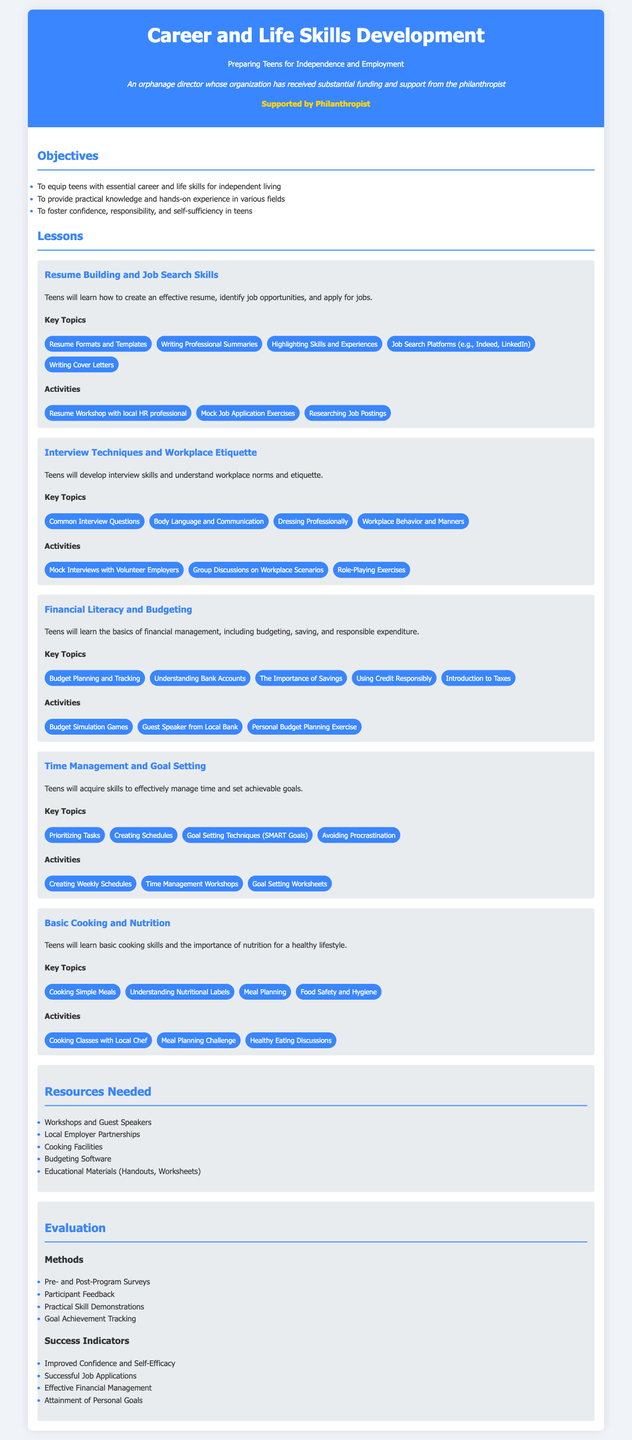What are the objectives of the lesson plan? The objectives are listed under the Objectives section in the document, specifically focusing on equipping teens with essential skills, providing practical knowledge, and fostering confidence.
Answer: To equip teens with essential career and life skills for independent living, To provide practical knowledge and hands-on experience in various fields, To foster confidence, responsibility, and self-sufficiency in teens What is the first lesson topic? The first lesson topic is presented in the Lessons section of the document.
Answer: Resume Building and Job Search Skills How many key topics are listed under Financial Literacy and Budgeting? The number of key topics is found in the Key Topics section for Financial Literacy and Budgeting.
Answer: Five What type of activities are included in the Interview Techniques and Workplace Etiquette lesson? The activities are specified under the Activities section for the Interview Techniques and Workplace Etiquette lesson.
Answer: Mock Interviews with Volunteer Employers, Group Discussions on Workplace Scenarios, Role-Playing Exercises What are the success indicators mentioned in the evaluation section? The success indicators are mentioned under the Success Indicators subsection in the evaluation section.
Answer: Improved Confidence and Self-Efficacy, Successful Job Applications, Effective Financial Management, Attainment of Personal Goals What is one resource needed for the program? A resource needed for the program is listed in the Resources Needed section.
Answer: Workshops and Guest Speakers How will the program participants be evaluated? The evaluation methods are outlined in the Evaluation section, detailing how participants will be assessed post-program.
Answer: Pre- and Post-Program Surveys, Participant Feedback, Practical Skill Demonstrations, Goal Achievement Tracking What is the theme of the lesson plan? The theme is reflected in the title of the document.
Answer: Career and Life Skills Development: Preparing Teens for Independence and Employment 